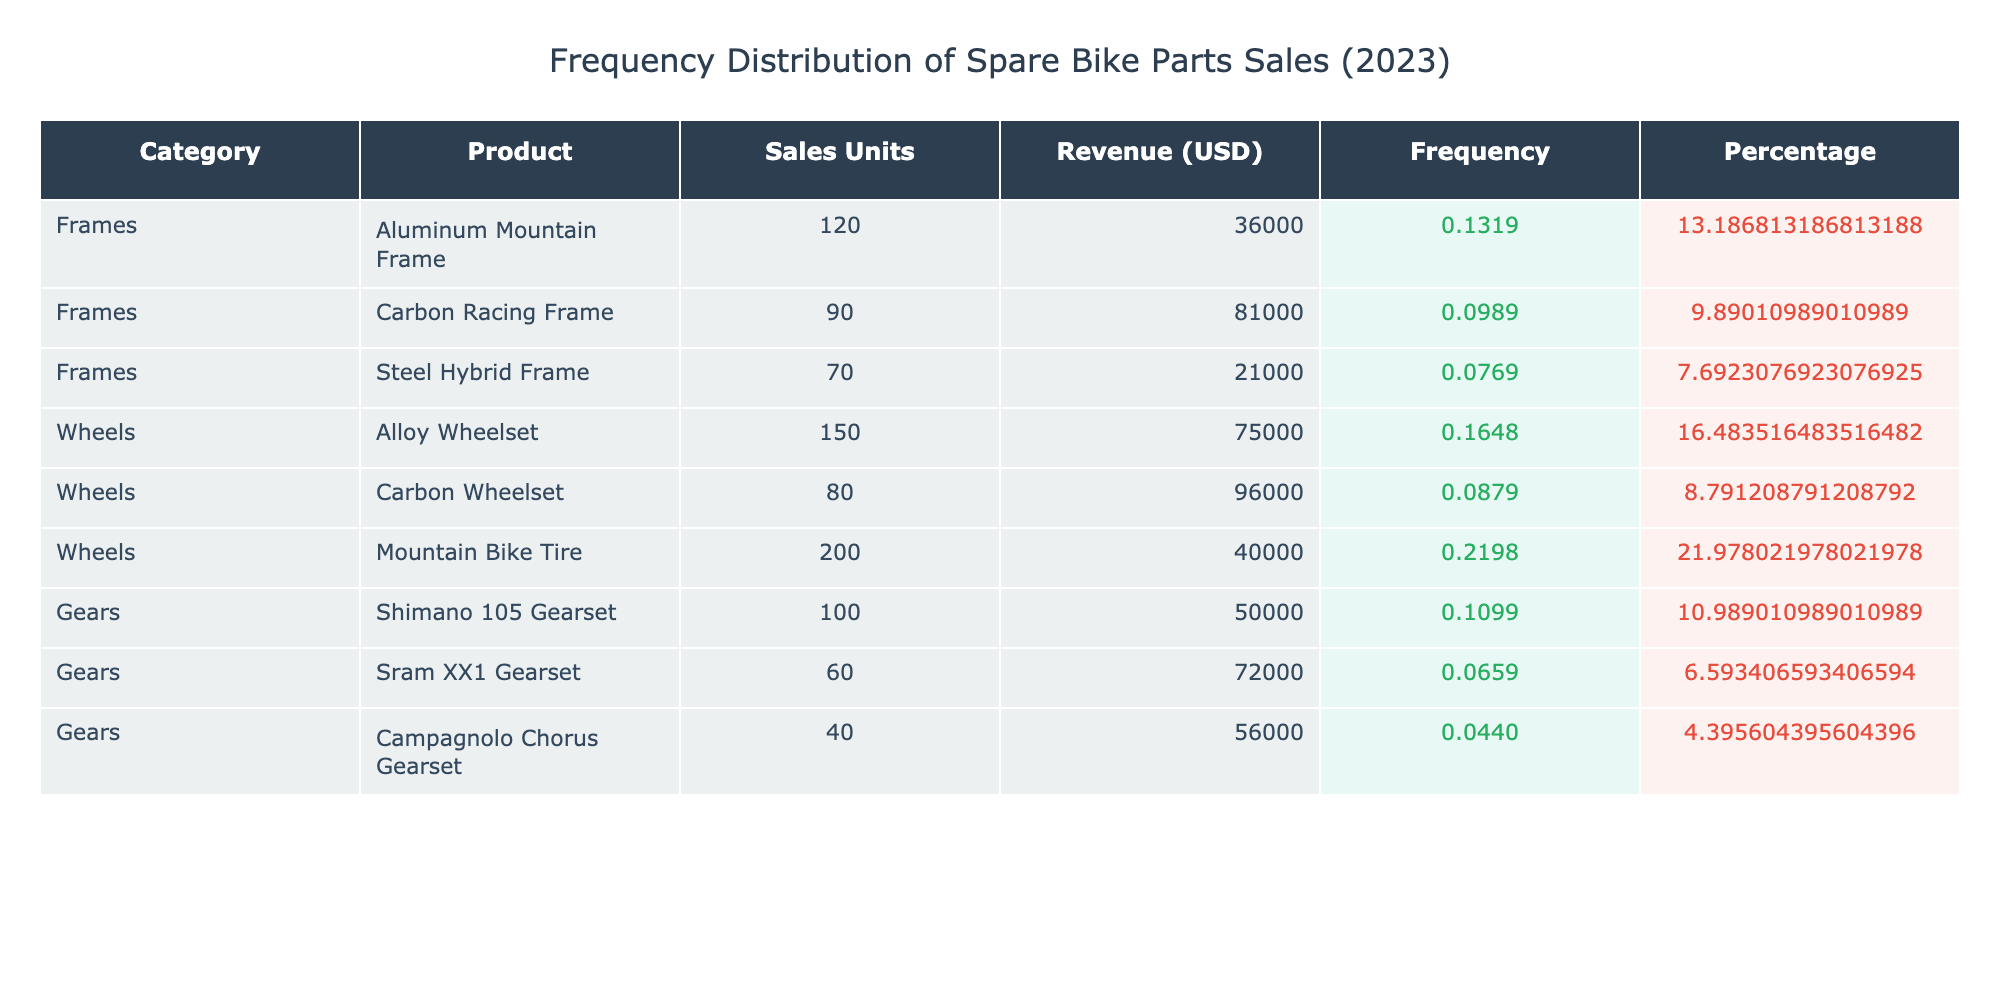What category had the highest sales units? By reviewing the Sales Units column, I can see that the Wheels category has the highest total sales with 430 units (150 + 80 + 200), compared to 280 for Frames (120 + 90 + 70) and 200 for Gears (100 + 60 + 40).
Answer: Wheels What is the total revenue generated from Gears? The total revenue for Gears is calculated by adding the revenue from each product in that category: 50000 + 72000 + 56000 = 178000 USD.
Answer: 178000 USD Is the revenue from the Carbon Racing Frame higher than that of the Shimano 105 Gearset? The revenue from Carbon Racing Frame is 81000 USD, whereas the revenue from Shimano 105 Gearset is 50000 USD. Since 81000 is greater than 50000, the statement is true.
Answer: Yes What is the frequency of sales units for Aluminum Mountain Frame? The total sales units are 1030. The sales units for Aluminum Mountain Frame is 120. Therefore, the frequency is 120 / 1030 = 0.1165 (approximately 11.65%).
Answer: 11.65% What category contributes the most to the total sales percentage? To find the contribution of each category, I take the total sales per category and calculate the percentage. Frames contribute 28.8% (280/1030*100), Wheels contribute 41.5% (430/1030*100), and Gears contribute 19.4% (200/1030*100). Wheels has the highest at 41.5%.
Answer: Wheels 